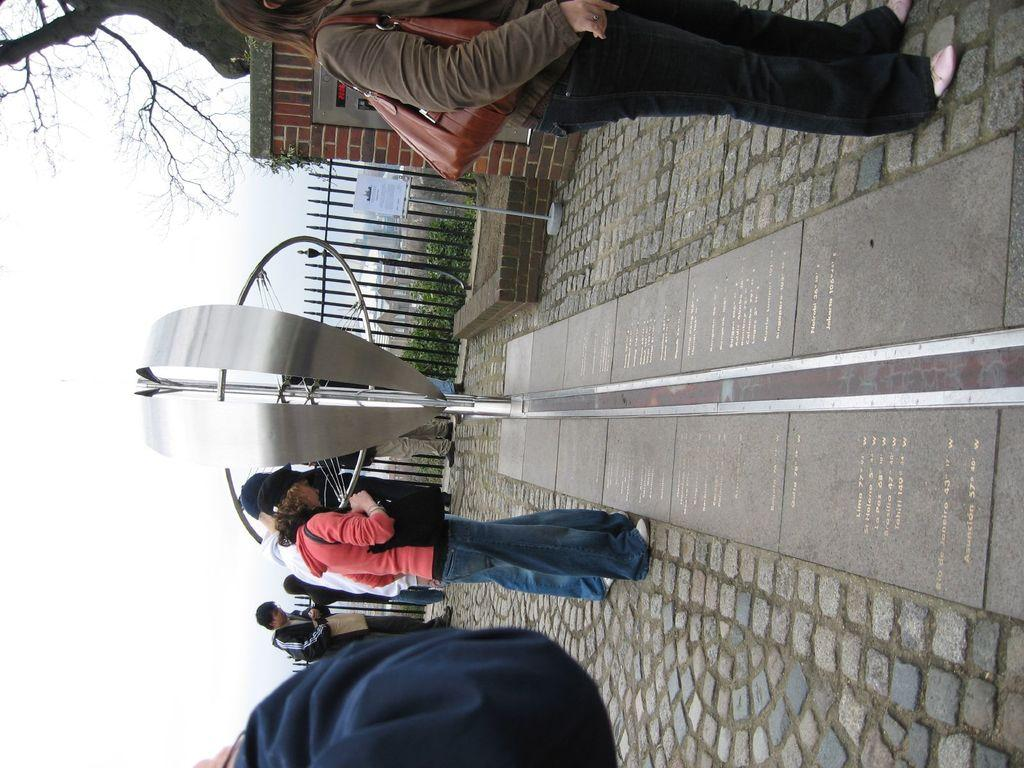Who is present in the image? There is a woman in the image. What is the woman doing in the image? The woman is standing in the image. What type of clothing is the woman wearing? The woman is wearing a sweater and jeans trousers. What can be seen on the left side of the image? There is a tree on the left side of the image. What type of tail can be seen on the woman in the image? There is no tail visible on the woman in the image. What is the reason for the woman standing in the image? The facts provided do not give any information about the reason for the woman standing in the image. 